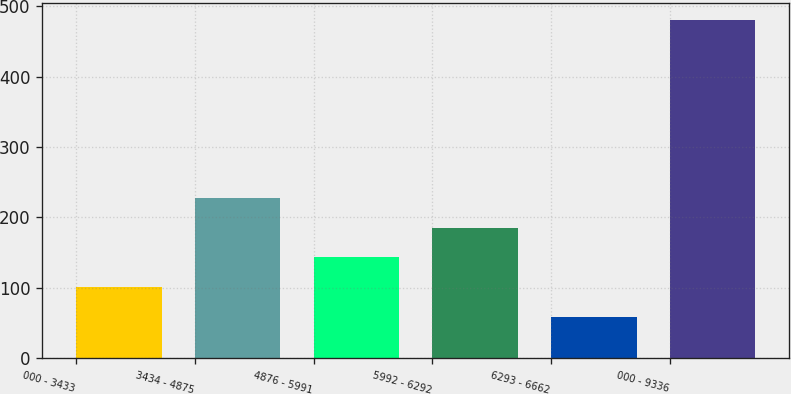Convert chart. <chart><loc_0><loc_0><loc_500><loc_500><bar_chart><fcel>000 - 3433<fcel>3434 - 4875<fcel>4876 - 5991<fcel>5992 - 6292<fcel>6293 - 6662<fcel>000 - 9336<nl><fcel>101.1<fcel>227.4<fcel>143.2<fcel>185.3<fcel>59<fcel>480<nl></chart> 